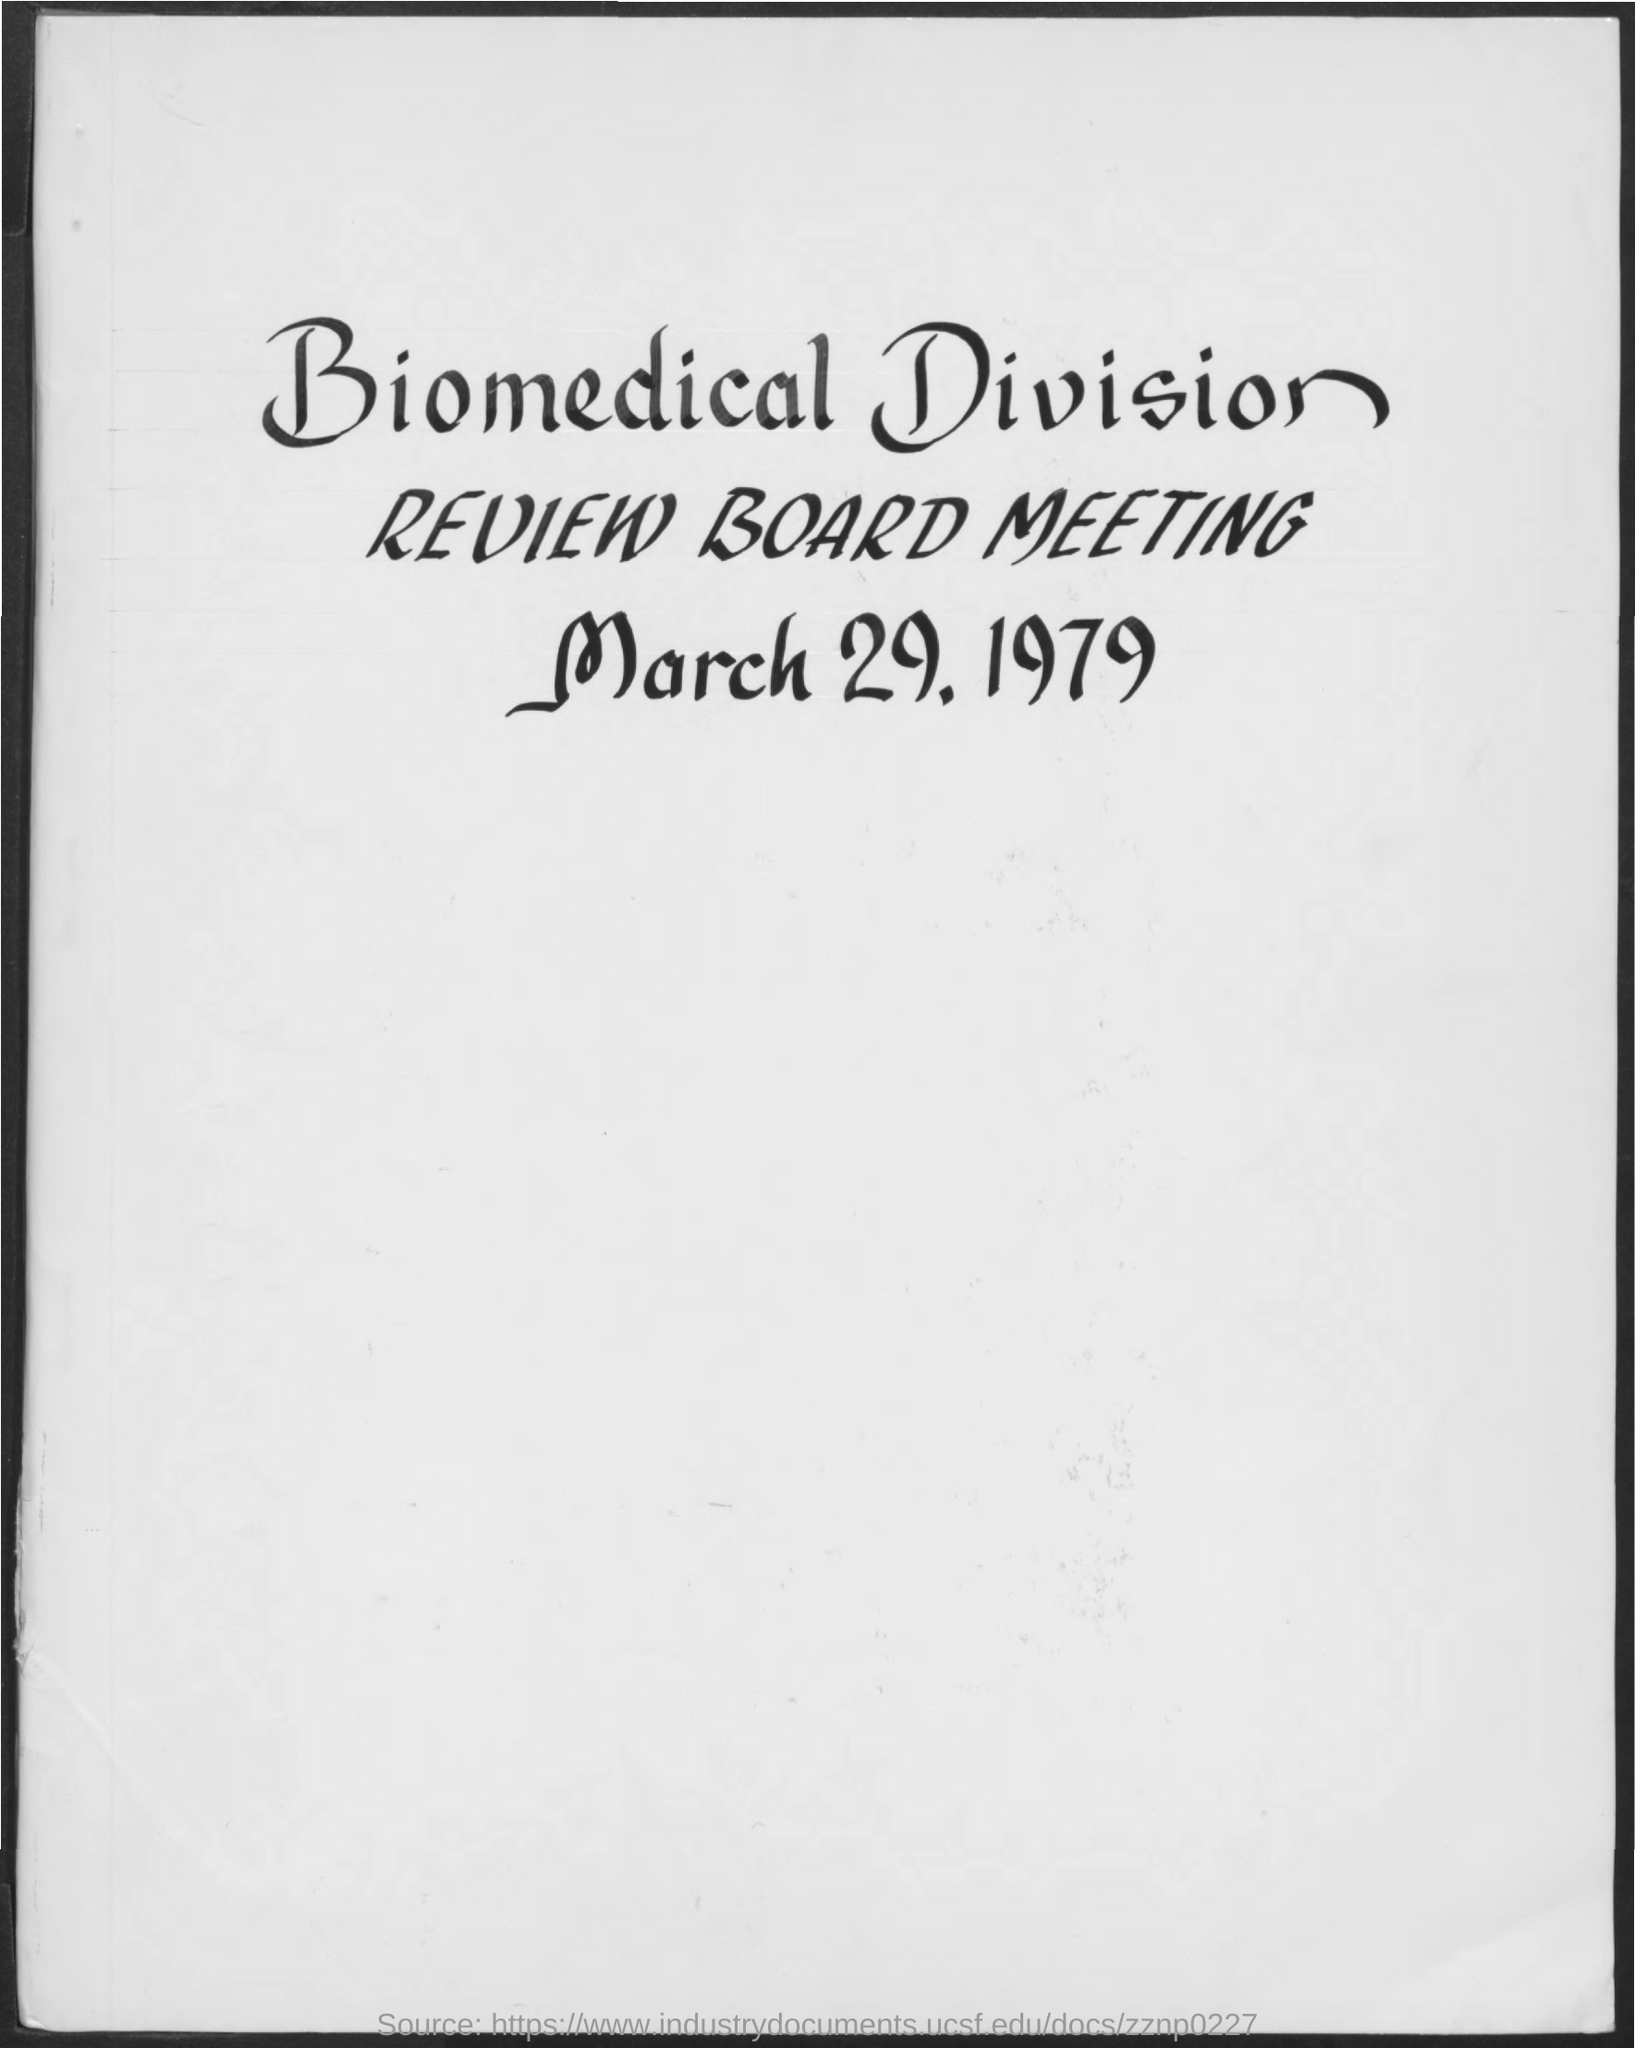When is the Biomedical Division Review Board Meeting held?
Provide a succinct answer. March 29. 1979. 